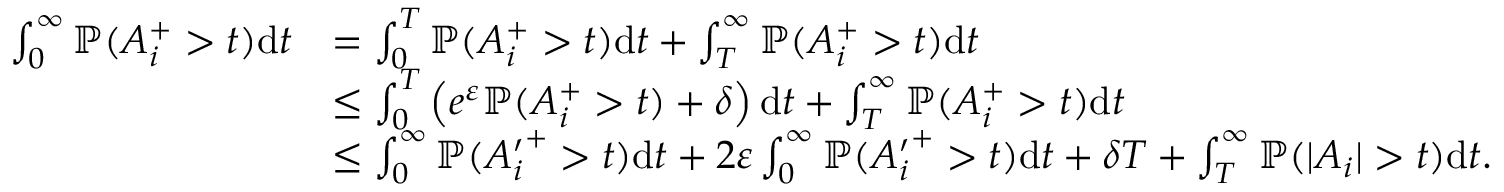<formula> <loc_0><loc_0><loc_500><loc_500>\begin{array} { r l } { \int _ { 0 } ^ { \infty } { \mathbb { P } } ( A _ { i } ^ { + } > t ) d t } & { = \int _ { 0 } ^ { T } { \mathbb { P } } ( A _ { i } ^ { + } > t ) d t + \int _ { T } ^ { \infty } { \mathbb { P } } ( A _ { i } ^ { + } > t ) d t } \\ & { \leq \int _ { 0 } ^ { T } \left ( e ^ { \varepsilon } { \mathbb { P } } ( A _ { i } ^ { + } > t ) + \delta \right ) d t + \int _ { T } ^ { \infty } { \mathbb { P } } ( A _ { i } ^ { + } > t ) d t } \\ & { \leq \int _ { 0 } ^ { \infty } { \mathbb { P } } ( { A _ { i } ^ { \prime } } ^ { + } > t ) d t + 2 \varepsilon \int _ { 0 } ^ { \infty } { \mathbb { P } } ( { A _ { i } ^ { \prime } } ^ { + } > t ) d t + \delta T + \int _ { T } ^ { \infty } { \mathbb { P } } ( | A _ { i } | > t ) d t . } \end{array}</formula> 